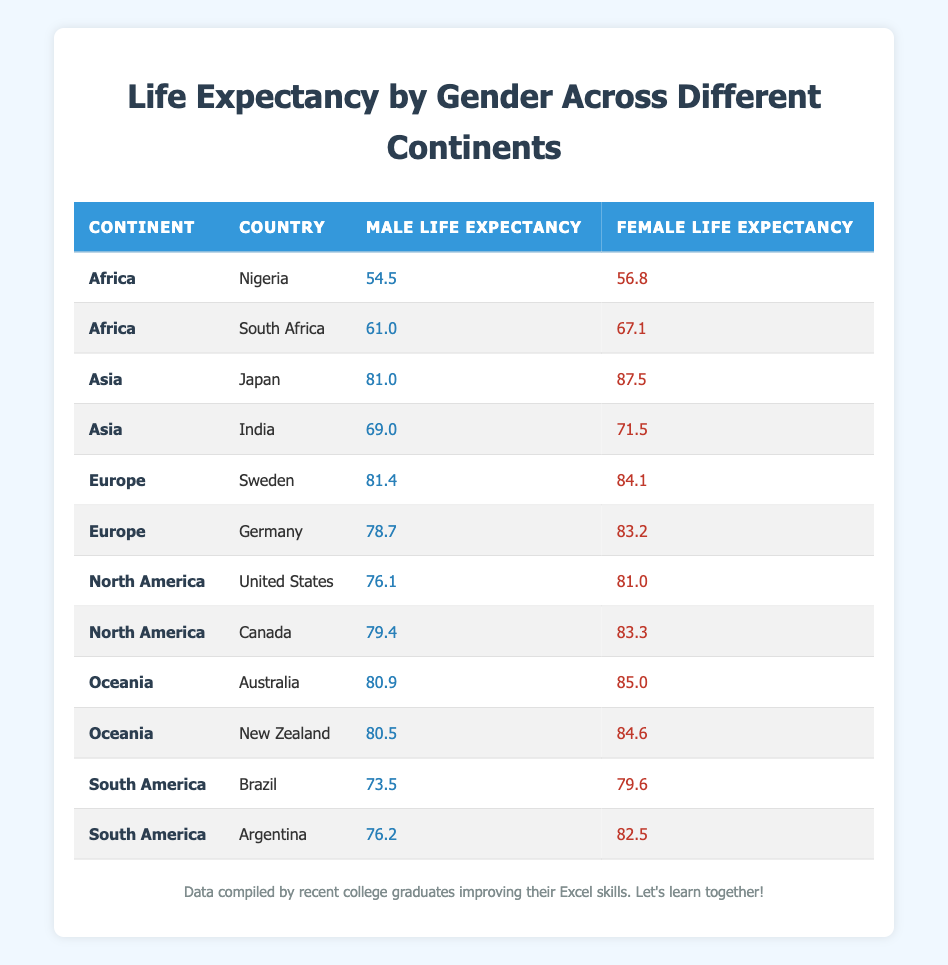What is the male life expectancy in Japan? The table provides the male life expectancy for Japan, which is explicitly listed as 81.0 years.
Answer: 81.0 Which continent has the highest female life expectancy? By examining the table, we can see that the highest female life expectancy is found in Japan (87.5), which belongs to the Asia continent.
Answer: Asia What is the difference in life expectancy between males and females in South Africa? The male life expectancy in South Africa is 61.0, and the female life expectancy is 67.1. To find the difference, subtract the male value from the female value: 67.1 - 61.0 = 6.1.
Answer: 6.1 Is the female life expectancy in Brazil higher than that in Nigeria? The female life expectancy in Brazil is 79.6, while in Nigeria, it is 56.8. Since 79.6 is greater than 56.8, the answer is yes.
Answer: Yes What is the average male life expectancy across all countries listed in the table? To find the average male life expectancy, we must add all male life expectancies together: 54.5 + 61.0 + 81.0 + 69.0 + 81.4 + 78.7 + 76.1 + 79.4 + 80.9 + 80.5 + 73.5 + 76.2 =  71.0 / 12 = 73.29, thus the average is 73.29 years.
Answer: 73.29 What is the female life expectancy in Canada? The table shows that the female life expectancy in Canada is 83.3 years.
Answer: 83.3 Which country in Africa has the lowest male life expectancy? From the table, Nigeria has a male life expectancy of 54.5, which is lower than South Africa's 61.0, making Nigeria the country with the lowest male life expectancy in Africa.
Answer: Nigeria Are males consistently having a lower life expectancy than females in all listed countries? By reviewing the table, we can confirm that in every country listed, the male life expectancy is less than the female life expectancy, indicating this is true.
Answer: Yes 